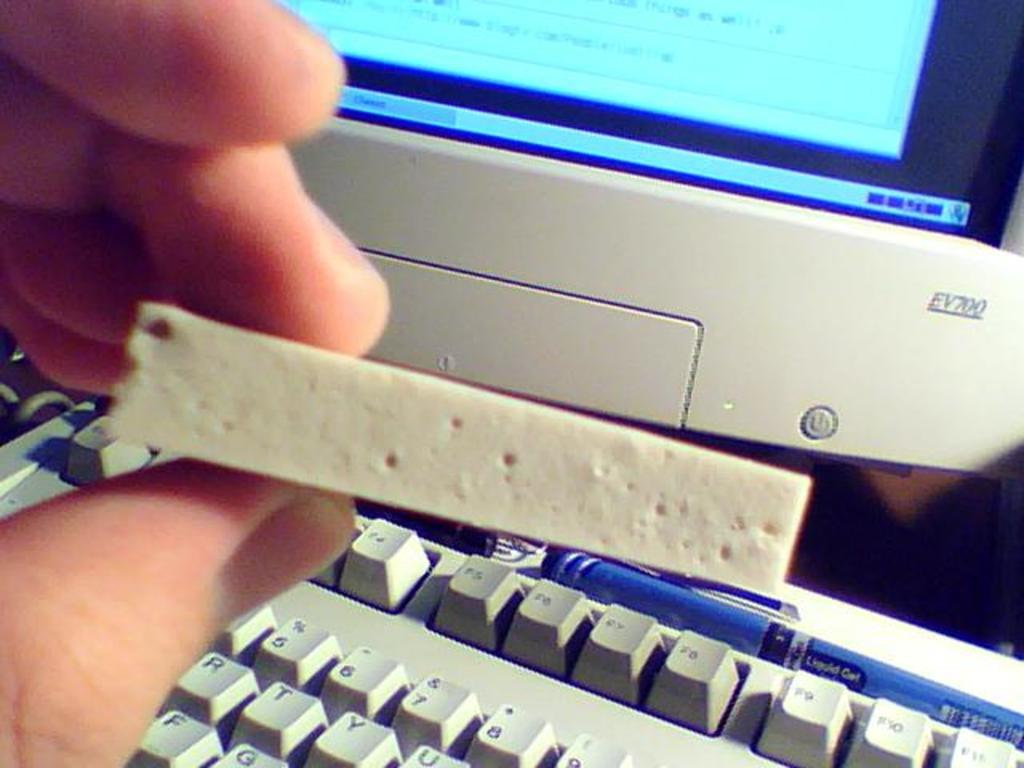<image>
Summarize the visual content of the image. A hand holds a white pitted object in front of a EV700 computer. 